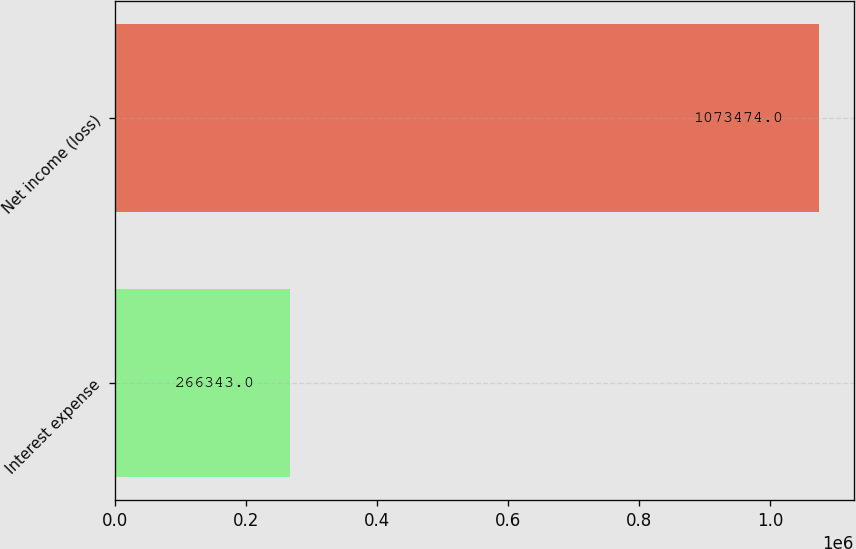Convert chart. <chart><loc_0><loc_0><loc_500><loc_500><bar_chart><fcel>Interest expense<fcel>Net income (loss)<nl><fcel>266343<fcel>1.07347e+06<nl></chart> 